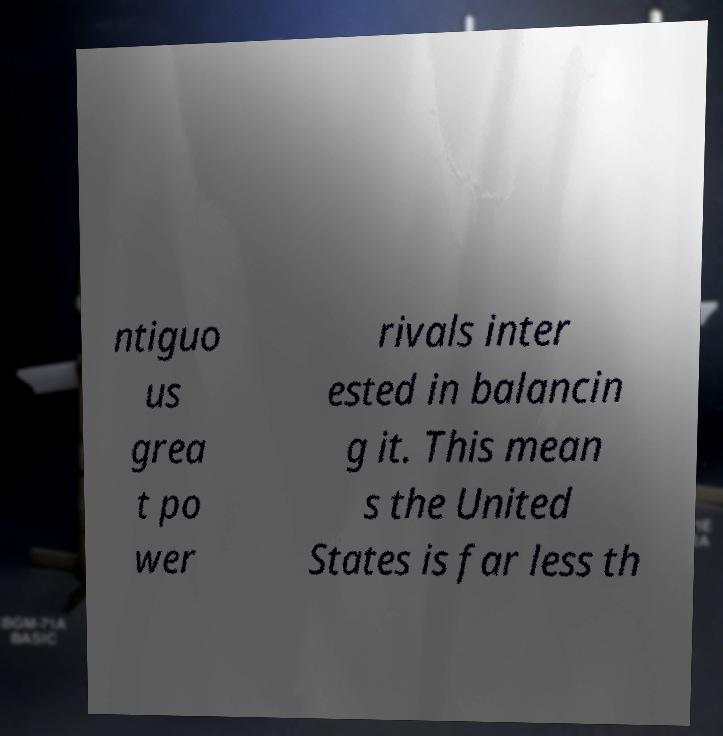Can you read and provide the text displayed in the image?This photo seems to have some interesting text. Can you extract and type it out for me? ntiguo us grea t po wer rivals inter ested in balancin g it. This mean s the United States is far less th 